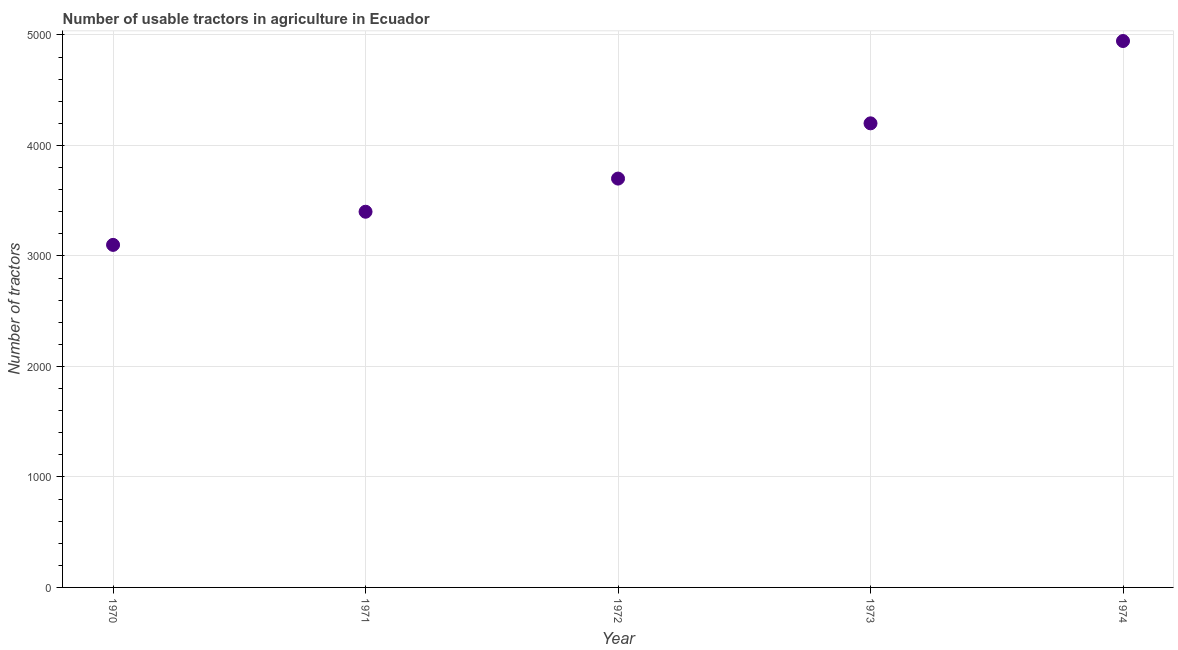What is the number of tractors in 1971?
Make the answer very short. 3400. Across all years, what is the maximum number of tractors?
Your answer should be compact. 4945. Across all years, what is the minimum number of tractors?
Provide a succinct answer. 3100. In which year was the number of tractors maximum?
Give a very brief answer. 1974. What is the sum of the number of tractors?
Your answer should be compact. 1.93e+04. What is the difference between the number of tractors in 1973 and 1974?
Offer a terse response. -745. What is the average number of tractors per year?
Ensure brevity in your answer.  3869. What is the median number of tractors?
Ensure brevity in your answer.  3700. What is the ratio of the number of tractors in 1972 to that in 1974?
Your answer should be compact. 0.75. Is the number of tractors in 1972 less than that in 1973?
Make the answer very short. Yes. Is the difference between the number of tractors in 1970 and 1972 greater than the difference between any two years?
Your response must be concise. No. What is the difference between the highest and the second highest number of tractors?
Provide a short and direct response. 745. What is the difference between the highest and the lowest number of tractors?
Provide a succinct answer. 1845. Does the number of tractors monotonically increase over the years?
Give a very brief answer. Yes. How many dotlines are there?
Keep it short and to the point. 1. What is the difference between two consecutive major ticks on the Y-axis?
Your response must be concise. 1000. Are the values on the major ticks of Y-axis written in scientific E-notation?
Keep it short and to the point. No. Does the graph contain any zero values?
Offer a terse response. No. Does the graph contain grids?
Your response must be concise. Yes. What is the title of the graph?
Ensure brevity in your answer.  Number of usable tractors in agriculture in Ecuador. What is the label or title of the X-axis?
Keep it short and to the point. Year. What is the label or title of the Y-axis?
Offer a terse response. Number of tractors. What is the Number of tractors in 1970?
Make the answer very short. 3100. What is the Number of tractors in 1971?
Your answer should be very brief. 3400. What is the Number of tractors in 1972?
Offer a terse response. 3700. What is the Number of tractors in 1973?
Ensure brevity in your answer.  4200. What is the Number of tractors in 1974?
Ensure brevity in your answer.  4945. What is the difference between the Number of tractors in 1970 and 1971?
Provide a succinct answer. -300. What is the difference between the Number of tractors in 1970 and 1972?
Make the answer very short. -600. What is the difference between the Number of tractors in 1970 and 1973?
Your response must be concise. -1100. What is the difference between the Number of tractors in 1970 and 1974?
Keep it short and to the point. -1845. What is the difference between the Number of tractors in 1971 and 1972?
Offer a very short reply. -300. What is the difference between the Number of tractors in 1971 and 1973?
Your answer should be very brief. -800. What is the difference between the Number of tractors in 1971 and 1974?
Your answer should be very brief. -1545. What is the difference between the Number of tractors in 1972 and 1973?
Keep it short and to the point. -500. What is the difference between the Number of tractors in 1972 and 1974?
Offer a terse response. -1245. What is the difference between the Number of tractors in 1973 and 1974?
Give a very brief answer. -745. What is the ratio of the Number of tractors in 1970 to that in 1971?
Your answer should be very brief. 0.91. What is the ratio of the Number of tractors in 1970 to that in 1972?
Provide a succinct answer. 0.84. What is the ratio of the Number of tractors in 1970 to that in 1973?
Give a very brief answer. 0.74. What is the ratio of the Number of tractors in 1970 to that in 1974?
Give a very brief answer. 0.63. What is the ratio of the Number of tractors in 1971 to that in 1972?
Make the answer very short. 0.92. What is the ratio of the Number of tractors in 1971 to that in 1973?
Make the answer very short. 0.81. What is the ratio of the Number of tractors in 1971 to that in 1974?
Your answer should be very brief. 0.69. What is the ratio of the Number of tractors in 1972 to that in 1973?
Ensure brevity in your answer.  0.88. What is the ratio of the Number of tractors in 1972 to that in 1974?
Your answer should be very brief. 0.75. What is the ratio of the Number of tractors in 1973 to that in 1974?
Offer a terse response. 0.85. 